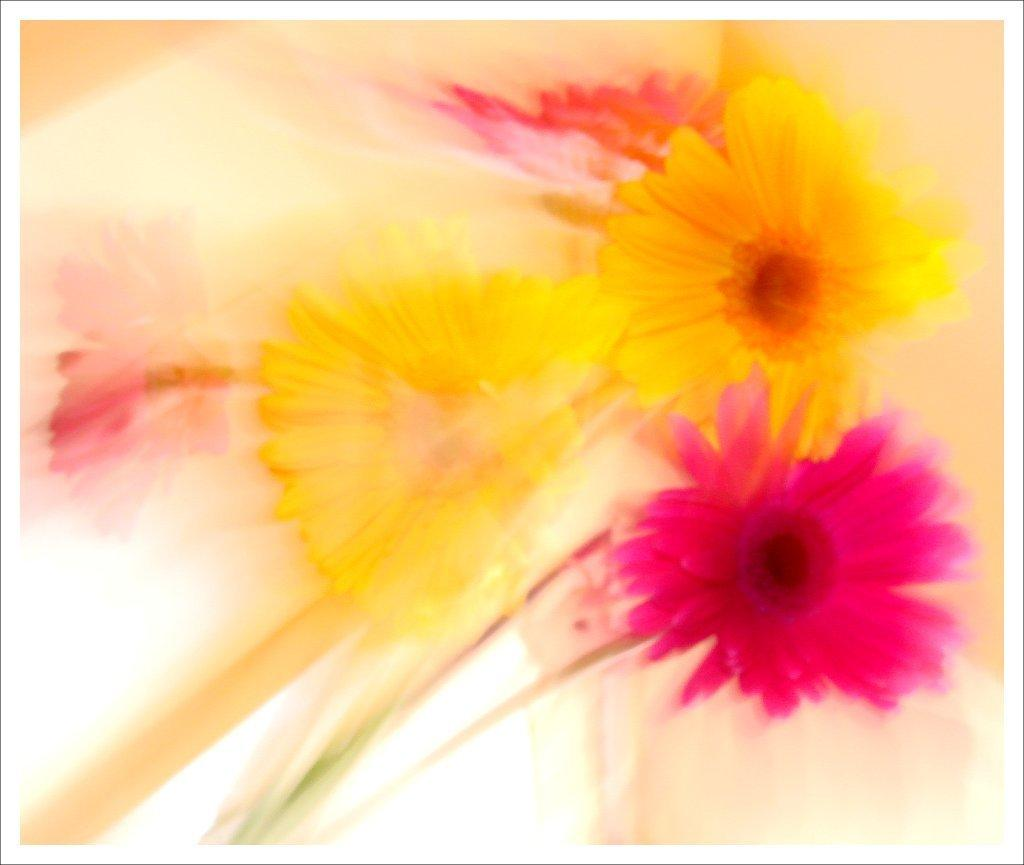What type of objects are present in the image? There are flowers in the image. What colors can be seen on the flowers? The flowers are in yellow and pink colors. How would you describe the background of the image? The background of the image is in white and cream colors. Can you see a bun in the image? There is no bun present in the image; it features flowers in yellow and pink colors with a white and cream background. 